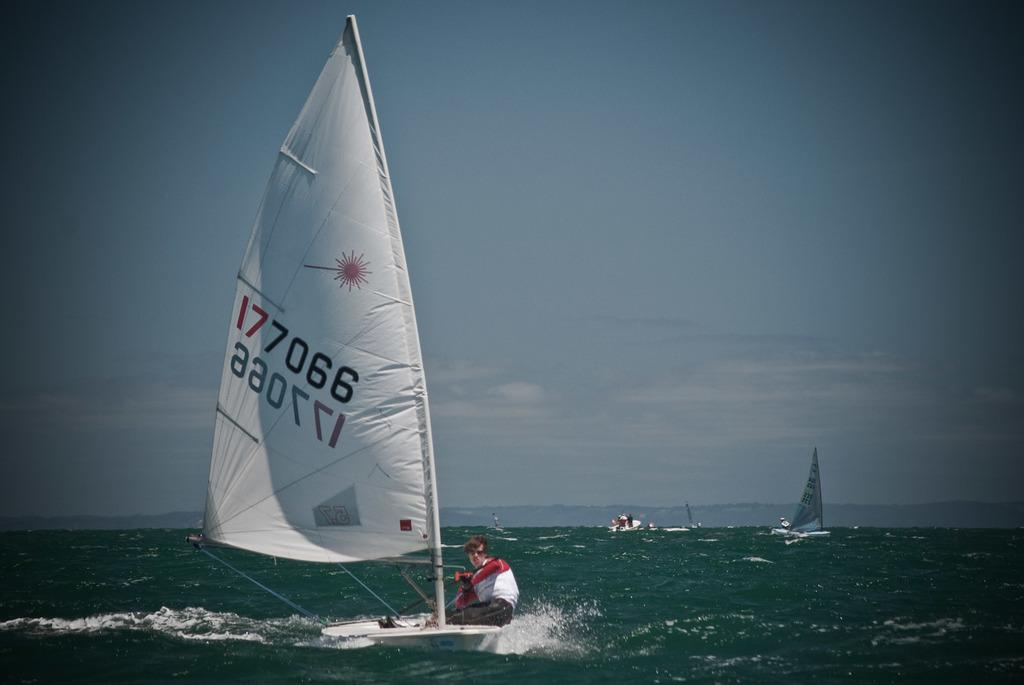What activity is the person in the image engaged in? The person is kitesurfing in the image. Where is the person kitesurfing? The person is on the water. What can be seen in the background of the image? There are boats sailing in the background of the image. How would you describe the weather based on the image? The sky is cloudy in the image. What type of shoe is the person wearing while kitesurfing in the image? There is no visible shoe on the person kitesurfing in the image, as they are wearing a wetsuit or other appropriate attire for water sports. 